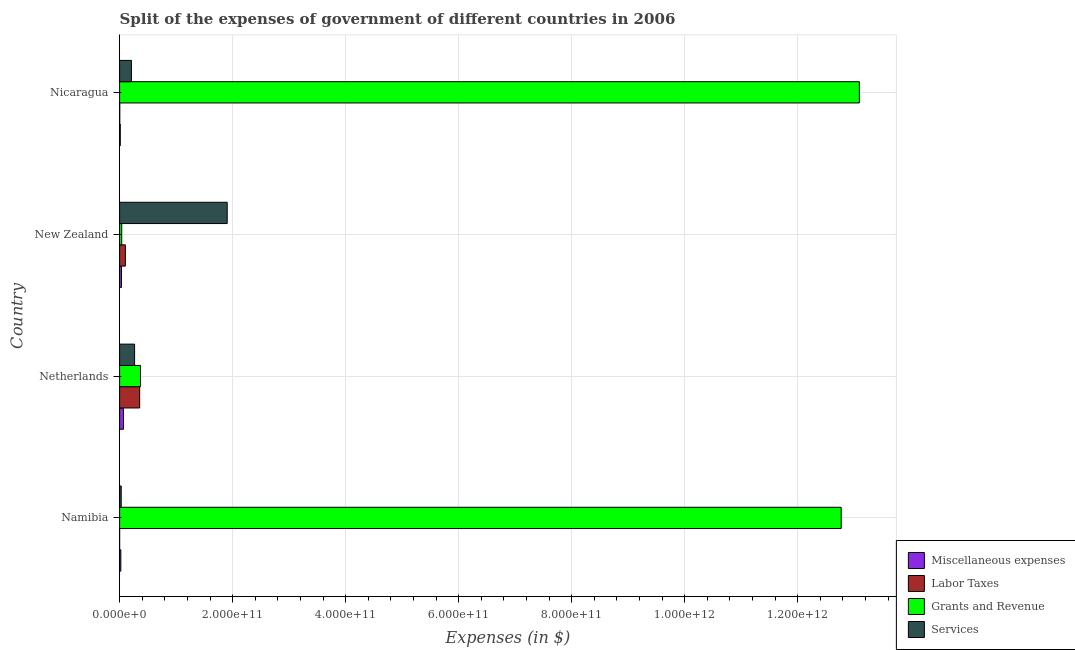How many different coloured bars are there?
Offer a terse response. 4. How many groups of bars are there?
Your answer should be compact. 4. Are the number of bars per tick equal to the number of legend labels?
Make the answer very short. Yes. How many bars are there on the 3rd tick from the bottom?
Your answer should be compact. 4. What is the label of the 1st group of bars from the top?
Offer a terse response. Nicaragua. What is the amount spent on miscellaneous expenses in Netherlands?
Give a very brief answer. 6.88e+09. Across all countries, what is the maximum amount spent on labor taxes?
Your answer should be very brief. 3.55e+1. Across all countries, what is the minimum amount spent on grants and revenue?
Your answer should be very brief. 3.73e+09. In which country was the amount spent on labor taxes maximum?
Keep it short and to the point. Netherlands. In which country was the amount spent on services minimum?
Provide a succinct answer. Namibia. What is the total amount spent on services in the graph?
Provide a short and direct response. 2.41e+11. What is the difference between the amount spent on services in Namibia and that in New Zealand?
Offer a terse response. -1.88e+11. What is the difference between the amount spent on services in New Zealand and the amount spent on labor taxes in Nicaragua?
Make the answer very short. 1.90e+11. What is the average amount spent on services per country?
Ensure brevity in your answer.  6.02e+1. What is the difference between the amount spent on services and amount spent on miscellaneous expenses in Netherlands?
Give a very brief answer. 1.97e+1. In how many countries, is the amount spent on miscellaneous expenses greater than 40000000000 $?
Give a very brief answer. 0. What is the ratio of the amount spent on services in Namibia to that in Nicaragua?
Provide a succinct answer. 0.14. What is the difference between the highest and the second highest amount spent on services?
Ensure brevity in your answer.  1.64e+11. What is the difference between the highest and the lowest amount spent on labor taxes?
Keep it short and to the point. 3.55e+1. Is the sum of the amount spent on labor taxes in Namibia and New Zealand greater than the maximum amount spent on miscellaneous expenses across all countries?
Your answer should be compact. Yes. What does the 1st bar from the top in Netherlands represents?
Your answer should be very brief. Services. What does the 2nd bar from the bottom in Nicaragua represents?
Provide a succinct answer. Labor Taxes. Is it the case that in every country, the sum of the amount spent on miscellaneous expenses and amount spent on labor taxes is greater than the amount spent on grants and revenue?
Keep it short and to the point. No. How many bars are there?
Keep it short and to the point. 16. Are all the bars in the graph horizontal?
Keep it short and to the point. Yes. How many countries are there in the graph?
Keep it short and to the point. 4. What is the difference between two consecutive major ticks on the X-axis?
Provide a short and direct response. 2.00e+11. Are the values on the major ticks of X-axis written in scientific E-notation?
Give a very brief answer. Yes. How many legend labels are there?
Keep it short and to the point. 4. What is the title of the graph?
Ensure brevity in your answer.  Split of the expenses of government of different countries in 2006. Does "Korea" appear as one of the legend labels in the graph?
Make the answer very short. No. What is the label or title of the X-axis?
Offer a very short reply. Expenses (in $). What is the Expenses (in $) of Miscellaneous expenses in Namibia?
Make the answer very short. 2.17e+09. What is the Expenses (in $) in Labor Taxes in Namibia?
Offer a terse response. 1.26e+07. What is the Expenses (in $) in Grants and Revenue in Namibia?
Offer a very short reply. 1.28e+12. What is the Expenses (in $) in Services in Namibia?
Give a very brief answer. 2.85e+09. What is the Expenses (in $) of Miscellaneous expenses in Netherlands?
Your answer should be very brief. 6.88e+09. What is the Expenses (in $) in Labor Taxes in Netherlands?
Offer a terse response. 3.55e+1. What is the Expenses (in $) in Grants and Revenue in Netherlands?
Your answer should be compact. 3.69e+1. What is the Expenses (in $) of Services in Netherlands?
Offer a terse response. 2.65e+1. What is the Expenses (in $) of Miscellaneous expenses in New Zealand?
Your answer should be very brief. 3.35e+09. What is the Expenses (in $) of Labor Taxes in New Zealand?
Offer a very short reply. 1.02e+1. What is the Expenses (in $) in Grants and Revenue in New Zealand?
Give a very brief answer. 3.73e+09. What is the Expenses (in $) in Services in New Zealand?
Give a very brief answer. 1.90e+11. What is the Expenses (in $) of Miscellaneous expenses in Nicaragua?
Make the answer very short. 1.19e+09. What is the Expenses (in $) of Labor Taxes in Nicaragua?
Ensure brevity in your answer.  2.73e+08. What is the Expenses (in $) in Grants and Revenue in Nicaragua?
Provide a short and direct response. 1.31e+12. What is the Expenses (in $) in Services in Nicaragua?
Offer a terse response. 2.09e+1. Across all countries, what is the maximum Expenses (in $) of Miscellaneous expenses?
Your answer should be very brief. 6.88e+09. Across all countries, what is the maximum Expenses (in $) in Labor Taxes?
Offer a terse response. 3.55e+1. Across all countries, what is the maximum Expenses (in $) of Grants and Revenue?
Provide a succinct answer. 1.31e+12. Across all countries, what is the maximum Expenses (in $) of Services?
Your answer should be compact. 1.90e+11. Across all countries, what is the minimum Expenses (in $) in Miscellaneous expenses?
Your answer should be very brief. 1.19e+09. Across all countries, what is the minimum Expenses (in $) of Labor Taxes?
Your answer should be very brief. 1.26e+07. Across all countries, what is the minimum Expenses (in $) in Grants and Revenue?
Make the answer very short. 3.73e+09. Across all countries, what is the minimum Expenses (in $) of Services?
Offer a terse response. 2.85e+09. What is the total Expenses (in $) of Miscellaneous expenses in the graph?
Give a very brief answer. 1.36e+1. What is the total Expenses (in $) of Labor Taxes in the graph?
Give a very brief answer. 4.60e+1. What is the total Expenses (in $) of Grants and Revenue in the graph?
Make the answer very short. 2.63e+12. What is the total Expenses (in $) of Services in the graph?
Offer a terse response. 2.41e+11. What is the difference between the Expenses (in $) in Miscellaneous expenses in Namibia and that in Netherlands?
Keep it short and to the point. -4.71e+09. What is the difference between the Expenses (in $) of Labor Taxes in Namibia and that in Netherlands?
Make the answer very short. -3.55e+1. What is the difference between the Expenses (in $) of Grants and Revenue in Namibia and that in Netherlands?
Give a very brief answer. 1.24e+12. What is the difference between the Expenses (in $) in Services in Namibia and that in Netherlands?
Your answer should be very brief. -2.37e+1. What is the difference between the Expenses (in $) in Miscellaneous expenses in Namibia and that in New Zealand?
Your answer should be very brief. -1.19e+09. What is the difference between the Expenses (in $) in Labor Taxes in Namibia and that in New Zealand?
Your response must be concise. -1.02e+1. What is the difference between the Expenses (in $) of Grants and Revenue in Namibia and that in New Zealand?
Your answer should be very brief. 1.27e+12. What is the difference between the Expenses (in $) of Services in Namibia and that in New Zealand?
Make the answer very short. -1.88e+11. What is the difference between the Expenses (in $) in Miscellaneous expenses in Namibia and that in Nicaragua?
Make the answer very short. 9.76e+08. What is the difference between the Expenses (in $) in Labor Taxes in Namibia and that in Nicaragua?
Your response must be concise. -2.60e+08. What is the difference between the Expenses (in $) of Grants and Revenue in Namibia and that in Nicaragua?
Provide a succinct answer. -3.22e+1. What is the difference between the Expenses (in $) in Services in Namibia and that in Nicaragua?
Keep it short and to the point. -1.81e+1. What is the difference between the Expenses (in $) of Miscellaneous expenses in Netherlands and that in New Zealand?
Your answer should be compact. 3.53e+09. What is the difference between the Expenses (in $) in Labor Taxes in Netherlands and that in New Zealand?
Offer a terse response. 2.53e+1. What is the difference between the Expenses (in $) in Grants and Revenue in Netherlands and that in New Zealand?
Your answer should be compact. 3.32e+1. What is the difference between the Expenses (in $) in Services in Netherlands and that in New Zealand?
Provide a succinct answer. -1.64e+11. What is the difference between the Expenses (in $) in Miscellaneous expenses in Netherlands and that in Nicaragua?
Your answer should be compact. 5.69e+09. What is the difference between the Expenses (in $) in Labor Taxes in Netherlands and that in Nicaragua?
Offer a terse response. 3.52e+1. What is the difference between the Expenses (in $) of Grants and Revenue in Netherlands and that in Nicaragua?
Offer a terse response. -1.27e+12. What is the difference between the Expenses (in $) in Services in Netherlands and that in Nicaragua?
Your answer should be compact. 5.61e+09. What is the difference between the Expenses (in $) of Miscellaneous expenses in New Zealand and that in Nicaragua?
Your answer should be compact. 2.16e+09. What is the difference between the Expenses (in $) in Labor Taxes in New Zealand and that in Nicaragua?
Your response must be concise. 9.94e+09. What is the difference between the Expenses (in $) of Grants and Revenue in New Zealand and that in Nicaragua?
Provide a short and direct response. -1.31e+12. What is the difference between the Expenses (in $) of Services in New Zealand and that in Nicaragua?
Give a very brief answer. 1.69e+11. What is the difference between the Expenses (in $) of Miscellaneous expenses in Namibia and the Expenses (in $) of Labor Taxes in Netherlands?
Give a very brief answer. -3.34e+1. What is the difference between the Expenses (in $) of Miscellaneous expenses in Namibia and the Expenses (in $) of Grants and Revenue in Netherlands?
Offer a terse response. -3.47e+1. What is the difference between the Expenses (in $) of Miscellaneous expenses in Namibia and the Expenses (in $) of Services in Netherlands?
Your answer should be very brief. -2.44e+1. What is the difference between the Expenses (in $) in Labor Taxes in Namibia and the Expenses (in $) in Grants and Revenue in Netherlands?
Ensure brevity in your answer.  -3.69e+1. What is the difference between the Expenses (in $) in Labor Taxes in Namibia and the Expenses (in $) in Services in Netherlands?
Make the answer very short. -2.65e+1. What is the difference between the Expenses (in $) of Grants and Revenue in Namibia and the Expenses (in $) of Services in Netherlands?
Make the answer very short. 1.25e+12. What is the difference between the Expenses (in $) in Miscellaneous expenses in Namibia and the Expenses (in $) in Labor Taxes in New Zealand?
Your answer should be compact. -8.05e+09. What is the difference between the Expenses (in $) of Miscellaneous expenses in Namibia and the Expenses (in $) of Grants and Revenue in New Zealand?
Provide a succinct answer. -1.57e+09. What is the difference between the Expenses (in $) in Miscellaneous expenses in Namibia and the Expenses (in $) in Services in New Zealand?
Make the answer very short. -1.88e+11. What is the difference between the Expenses (in $) in Labor Taxes in Namibia and the Expenses (in $) in Grants and Revenue in New Zealand?
Make the answer very short. -3.72e+09. What is the difference between the Expenses (in $) in Labor Taxes in Namibia and the Expenses (in $) in Services in New Zealand?
Keep it short and to the point. -1.90e+11. What is the difference between the Expenses (in $) in Grants and Revenue in Namibia and the Expenses (in $) in Services in New Zealand?
Provide a short and direct response. 1.09e+12. What is the difference between the Expenses (in $) of Miscellaneous expenses in Namibia and the Expenses (in $) of Labor Taxes in Nicaragua?
Give a very brief answer. 1.89e+09. What is the difference between the Expenses (in $) of Miscellaneous expenses in Namibia and the Expenses (in $) of Grants and Revenue in Nicaragua?
Your response must be concise. -1.31e+12. What is the difference between the Expenses (in $) of Miscellaneous expenses in Namibia and the Expenses (in $) of Services in Nicaragua?
Your response must be concise. -1.88e+1. What is the difference between the Expenses (in $) of Labor Taxes in Namibia and the Expenses (in $) of Grants and Revenue in Nicaragua?
Offer a very short reply. -1.31e+12. What is the difference between the Expenses (in $) in Labor Taxes in Namibia and the Expenses (in $) in Services in Nicaragua?
Your answer should be very brief. -2.09e+1. What is the difference between the Expenses (in $) in Grants and Revenue in Namibia and the Expenses (in $) in Services in Nicaragua?
Your response must be concise. 1.26e+12. What is the difference between the Expenses (in $) of Miscellaneous expenses in Netherlands and the Expenses (in $) of Labor Taxes in New Zealand?
Your answer should be compact. -3.33e+09. What is the difference between the Expenses (in $) in Miscellaneous expenses in Netherlands and the Expenses (in $) in Grants and Revenue in New Zealand?
Offer a terse response. 3.15e+09. What is the difference between the Expenses (in $) of Miscellaneous expenses in Netherlands and the Expenses (in $) of Services in New Zealand?
Provide a succinct answer. -1.84e+11. What is the difference between the Expenses (in $) of Labor Taxes in Netherlands and the Expenses (in $) of Grants and Revenue in New Zealand?
Provide a short and direct response. 3.18e+1. What is the difference between the Expenses (in $) in Labor Taxes in Netherlands and the Expenses (in $) in Services in New Zealand?
Give a very brief answer. -1.55e+11. What is the difference between the Expenses (in $) of Grants and Revenue in Netherlands and the Expenses (in $) of Services in New Zealand?
Keep it short and to the point. -1.53e+11. What is the difference between the Expenses (in $) in Miscellaneous expenses in Netherlands and the Expenses (in $) in Labor Taxes in Nicaragua?
Your answer should be very brief. 6.61e+09. What is the difference between the Expenses (in $) in Miscellaneous expenses in Netherlands and the Expenses (in $) in Grants and Revenue in Nicaragua?
Provide a succinct answer. -1.30e+12. What is the difference between the Expenses (in $) in Miscellaneous expenses in Netherlands and the Expenses (in $) in Services in Nicaragua?
Your answer should be compact. -1.40e+1. What is the difference between the Expenses (in $) in Labor Taxes in Netherlands and the Expenses (in $) in Grants and Revenue in Nicaragua?
Your answer should be very brief. -1.27e+12. What is the difference between the Expenses (in $) in Labor Taxes in Netherlands and the Expenses (in $) in Services in Nicaragua?
Your answer should be compact. 1.46e+1. What is the difference between the Expenses (in $) of Grants and Revenue in Netherlands and the Expenses (in $) of Services in Nicaragua?
Provide a short and direct response. 1.60e+1. What is the difference between the Expenses (in $) of Miscellaneous expenses in New Zealand and the Expenses (in $) of Labor Taxes in Nicaragua?
Ensure brevity in your answer.  3.08e+09. What is the difference between the Expenses (in $) of Miscellaneous expenses in New Zealand and the Expenses (in $) of Grants and Revenue in Nicaragua?
Make the answer very short. -1.31e+12. What is the difference between the Expenses (in $) of Miscellaneous expenses in New Zealand and the Expenses (in $) of Services in Nicaragua?
Offer a terse response. -1.76e+1. What is the difference between the Expenses (in $) in Labor Taxes in New Zealand and the Expenses (in $) in Grants and Revenue in Nicaragua?
Give a very brief answer. -1.30e+12. What is the difference between the Expenses (in $) in Labor Taxes in New Zealand and the Expenses (in $) in Services in Nicaragua?
Provide a short and direct response. -1.07e+1. What is the difference between the Expenses (in $) in Grants and Revenue in New Zealand and the Expenses (in $) in Services in Nicaragua?
Provide a short and direct response. -1.72e+1. What is the average Expenses (in $) of Miscellaneous expenses per country?
Give a very brief answer. 3.40e+09. What is the average Expenses (in $) of Labor Taxes per country?
Provide a succinct answer. 1.15e+1. What is the average Expenses (in $) in Grants and Revenue per country?
Your answer should be compact. 6.57e+11. What is the average Expenses (in $) of Services per country?
Offer a very short reply. 6.02e+1. What is the difference between the Expenses (in $) in Miscellaneous expenses and Expenses (in $) in Labor Taxes in Namibia?
Ensure brevity in your answer.  2.15e+09. What is the difference between the Expenses (in $) of Miscellaneous expenses and Expenses (in $) of Grants and Revenue in Namibia?
Offer a terse response. -1.27e+12. What is the difference between the Expenses (in $) of Miscellaneous expenses and Expenses (in $) of Services in Namibia?
Provide a succinct answer. -6.83e+08. What is the difference between the Expenses (in $) in Labor Taxes and Expenses (in $) in Grants and Revenue in Namibia?
Provide a short and direct response. -1.28e+12. What is the difference between the Expenses (in $) in Labor Taxes and Expenses (in $) in Services in Namibia?
Ensure brevity in your answer.  -2.84e+09. What is the difference between the Expenses (in $) of Grants and Revenue and Expenses (in $) of Services in Namibia?
Your response must be concise. 1.27e+12. What is the difference between the Expenses (in $) of Miscellaneous expenses and Expenses (in $) of Labor Taxes in Netherlands?
Make the answer very short. -2.86e+1. What is the difference between the Expenses (in $) in Miscellaneous expenses and Expenses (in $) in Grants and Revenue in Netherlands?
Provide a succinct answer. -3.00e+1. What is the difference between the Expenses (in $) of Miscellaneous expenses and Expenses (in $) of Services in Netherlands?
Provide a short and direct response. -1.97e+1. What is the difference between the Expenses (in $) in Labor Taxes and Expenses (in $) in Grants and Revenue in Netherlands?
Offer a terse response. -1.40e+09. What is the difference between the Expenses (in $) of Labor Taxes and Expenses (in $) of Services in Netherlands?
Provide a succinct answer. 8.98e+09. What is the difference between the Expenses (in $) in Grants and Revenue and Expenses (in $) in Services in Netherlands?
Give a very brief answer. 1.04e+1. What is the difference between the Expenses (in $) in Miscellaneous expenses and Expenses (in $) in Labor Taxes in New Zealand?
Your response must be concise. -6.86e+09. What is the difference between the Expenses (in $) of Miscellaneous expenses and Expenses (in $) of Grants and Revenue in New Zealand?
Give a very brief answer. -3.82e+08. What is the difference between the Expenses (in $) in Miscellaneous expenses and Expenses (in $) in Services in New Zealand?
Provide a short and direct response. -1.87e+11. What is the difference between the Expenses (in $) of Labor Taxes and Expenses (in $) of Grants and Revenue in New Zealand?
Offer a very short reply. 6.48e+09. What is the difference between the Expenses (in $) of Labor Taxes and Expenses (in $) of Services in New Zealand?
Your response must be concise. -1.80e+11. What is the difference between the Expenses (in $) in Grants and Revenue and Expenses (in $) in Services in New Zealand?
Offer a very short reply. -1.87e+11. What is the difference between the Expenses (in $) of Miscellaneous expenses and Expenses (in $) of Labor Taxes in Nicaragua?
Offer a terse response. 9.17e+08. What is the difference between the Expenses (in $) in Miscellaneous expenses and Expenses (in $) in Grants and Revenue in Nicaragua?
Your answer should be very brief. -1.31e+12. What is the difference between the Expenses (in $) in Miscellaneous expenses and Expenses (in $) in Services in Nicaragua?
Make the answer very short. -1.97e+1. What is the difference between the Expenses (in $) in Labor Taxes and Expenses (in $) in Grants and Revenue in Nicaragua?
Provide a short and direct response. -1.31e+12. What is the difference between the Expenses (in $) of Labor Taxes and Expenses (in $) of Services in Nicaragua?
Ensure brevity in your answer.  -2.07e+1. What is the difference between the Expenses (in $) of Grants and Revenue and Expenses (in $) of Services in Nicaragua?
Offer a terse response. 1.29e+12. What is the ratio of the Expenses (in $) in Miscellaneous expenses in Namibia to that in Netherlands?
Make the answer very short. 0.31. What is the ratio of the Expenses (in $) in Grants and Revenue in Namibia to that in Netherlands?
Provide a short and direct response. 34.59. What is the ratio of the Expenses (in $) in Services in Namibia to that in Netherlands?
Your answer should be compact. 0.11. What is the ratio of the Expenses (in $) in Miscellaneous expenses in Namibia to that in New Zealand?
Provide a short and direct response. 0.65. What is the ratio of the Expenses (in $) in Labor Taxes in Namibia to that in New Zealand?
Ensure brevity in your answer.  0. What is the ratio of the Expenses (in $) of Grants and Revenue in Namibia to that in New Zealand?
Provide a short and direct response. 341.94. What is the ratio of the Expenses (in $) of Services in Namibia to that in New Zealand?
Your response must be concise. 0.01. What is the ratio of the Expenses (in $) in Miscellaneous expenses in Namibia to that in Nicaragua?
Ensure brevity in your answer.  1.82. What is the ratio of the Expenses (in $) of Labor Taxes in Namibia to that in Nicaragua?
Offer a terse response. 0.05. What is the ratio of the Expenses (in $) in Grants and Revenue in Namibia to that in Nicaragua?
Your answer should be very brief. 0.98. What is the ratio of the Expenses (in $) in Services in Namibia to that in Nicaragua?
Make the answer very short. 0.14. What is the ratio of the Expenses (in $) of Miscellaneous expenses in Netherlands to that in New Zealand?
Your answer should be very brief. 2.05. What is the ratio of the Expenses (in $) of Labor Taxes in Netherlands to that in New Zealand?
Make the answer very short. 3.48. What is the ratio of the Expenses (in $) in Grants and Revenue in Netherlands to that in New Zealand?
Provide a short and direct response. 9.89. What is the ratio of the Expenses (in $) of Services in Netherlands to that in New Zealand?
Provide a succinct answer. 0.14. What is the ratio of the Expenses (in $) in Miscellaneous expenses in Netherlands to that in Nicaragua?
Keep it short and to the point. 5.78. What is the ratio of the Expenses (in $) in Labor Taxes in Netherlands to that in Nicaragua?
Your response must be concise. 130.32. What is the ratio of the Expenses (in $) of Grants and Revenue in Netherlands to that in Nicaragua?
Ensure brevity in your answer.  0.03. What is the ratio of the Expenses (in $) of Services in Netherlands to that in Nicaragua?
Your answer should be very brief. 1.27. What is the ratio of the Expenses (in $) in Miscellaneous expenses in New Zealand to that in Nicaragua?
Ensure brevity in your answer.  2.82. What is the ratio of the Expenses (in $) in Labor Taxes in New Zealand to that in Nicaragua?
Provide a short and direct response. 37.47. What is the ratio of the Expenses (in $) of Grants and Revenue in New Zealand to that in Nicaragua?
Your response must be concise. 0. What is the difference between the highest and the second highest Expenses (in $) of Miscellaneous expenses?
Provide a succinct answer. 3.53e+09. What is the difference between the highest and the second highest Expenses (in $) in Labor Taxes?
Your response must be concise. 2.53e+1. What is the difference between the highest and the second highest Expenses (in $) in Grants and Revenue?
Your answer should be compact. 3.22e+1. What is the difference between the highest and the second highest Expenses (in $) of Services?
Your answer should be compact. 1.64e+11. What is the difference between the highest and the lowest Expenses (in $) in Miscellaneous expenses?
Ensure brevity in your answer.  5.69e+09. What is the difference between the highest and the lowest Expenses (in $) in Labor Taxes?
Keep it short and to the point. 3.55e+1. What is the difference between the highest and the lowest Expenses (in $) of Grants and Revenue?
Provide a succinct answer. 1.31e+12. What is the difference between the highest and the lowest Expenses (in $) in Services?
Make the answer very short. 1.88e+11. 